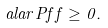Convert formula to latex. <formula><loc_0><loc_0><loc_500><loc_500>a l a r { P f } { f } \geq 0 .</formula> 